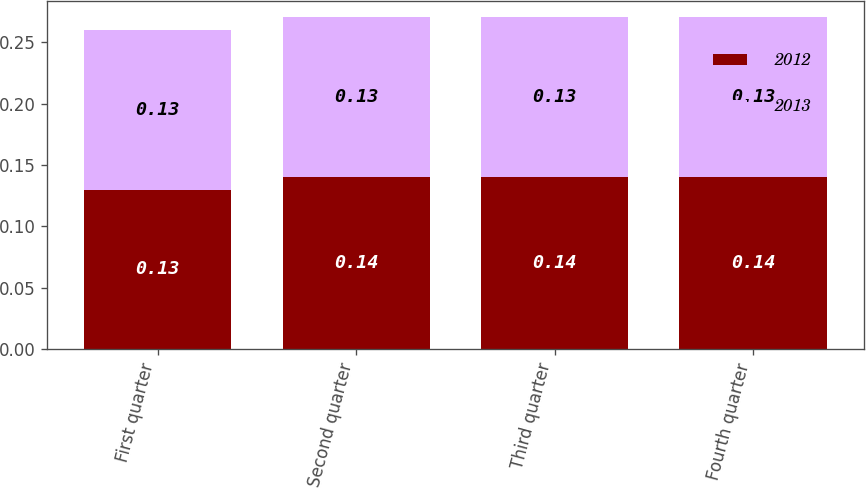Convert chart. <chart><loc_0><loc_0><loc_500><loc_500><stacked_bar_chart><ecel><fcel>First quarter<fcel>Second quarter<fcel>Third quarter<fcel>Fourth quarter<nl><fcel>2012<fcel>0.13<fcel>0.14<fcel>0.14<fcel>0.14<nl><fcel>2013<fcel>0.13<fcel>0.13<fcel>0.13<fcel>0.13<nl></chart> 